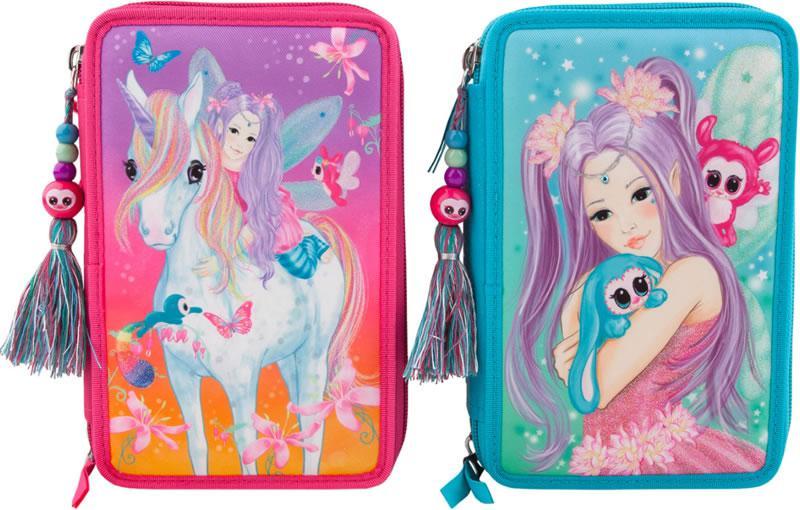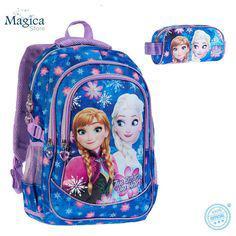The first image is the image on the left, the second image is the image on the right. Considering the images on both sides, is "One of the two images has a bag with the characters from Disney's Frozen on it." valid? Answer yes or no. Yes. 